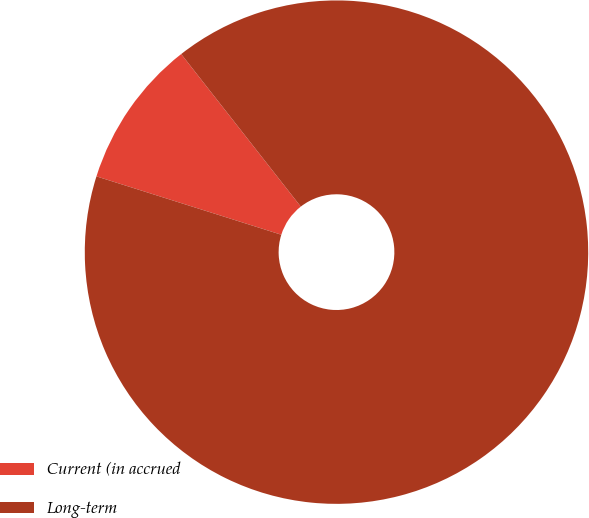Convert chart to OTSL. <chart><loc_0><loc_0><loc_500><loc_500><pie_chart><fcel>Current (in accrued<fcel>Long-term<nl><fcel>9.55%<fcel>90.45%<nl></chart> 